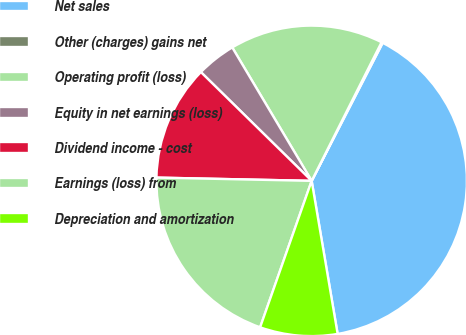Convert chart to OTSL. <chart><loc_0><loc_0><loc_500><loc_500><pie_chart><fcel>Net sales<fcel>Other (charges) gains net<fcel>Operating profit (loss)<fcel>Equity in net earnings (loss)<fcel>Dividend income - cost<fcel>Earnings (loss) from<fcel>Depreciation and amortization<nl><fcel>39.76%<fcel>0.13%<fcel>15.98%<fcel>4.1%<fcel>12.02%<fcel>19.95%<fcel>8.06%<nl></chart> 